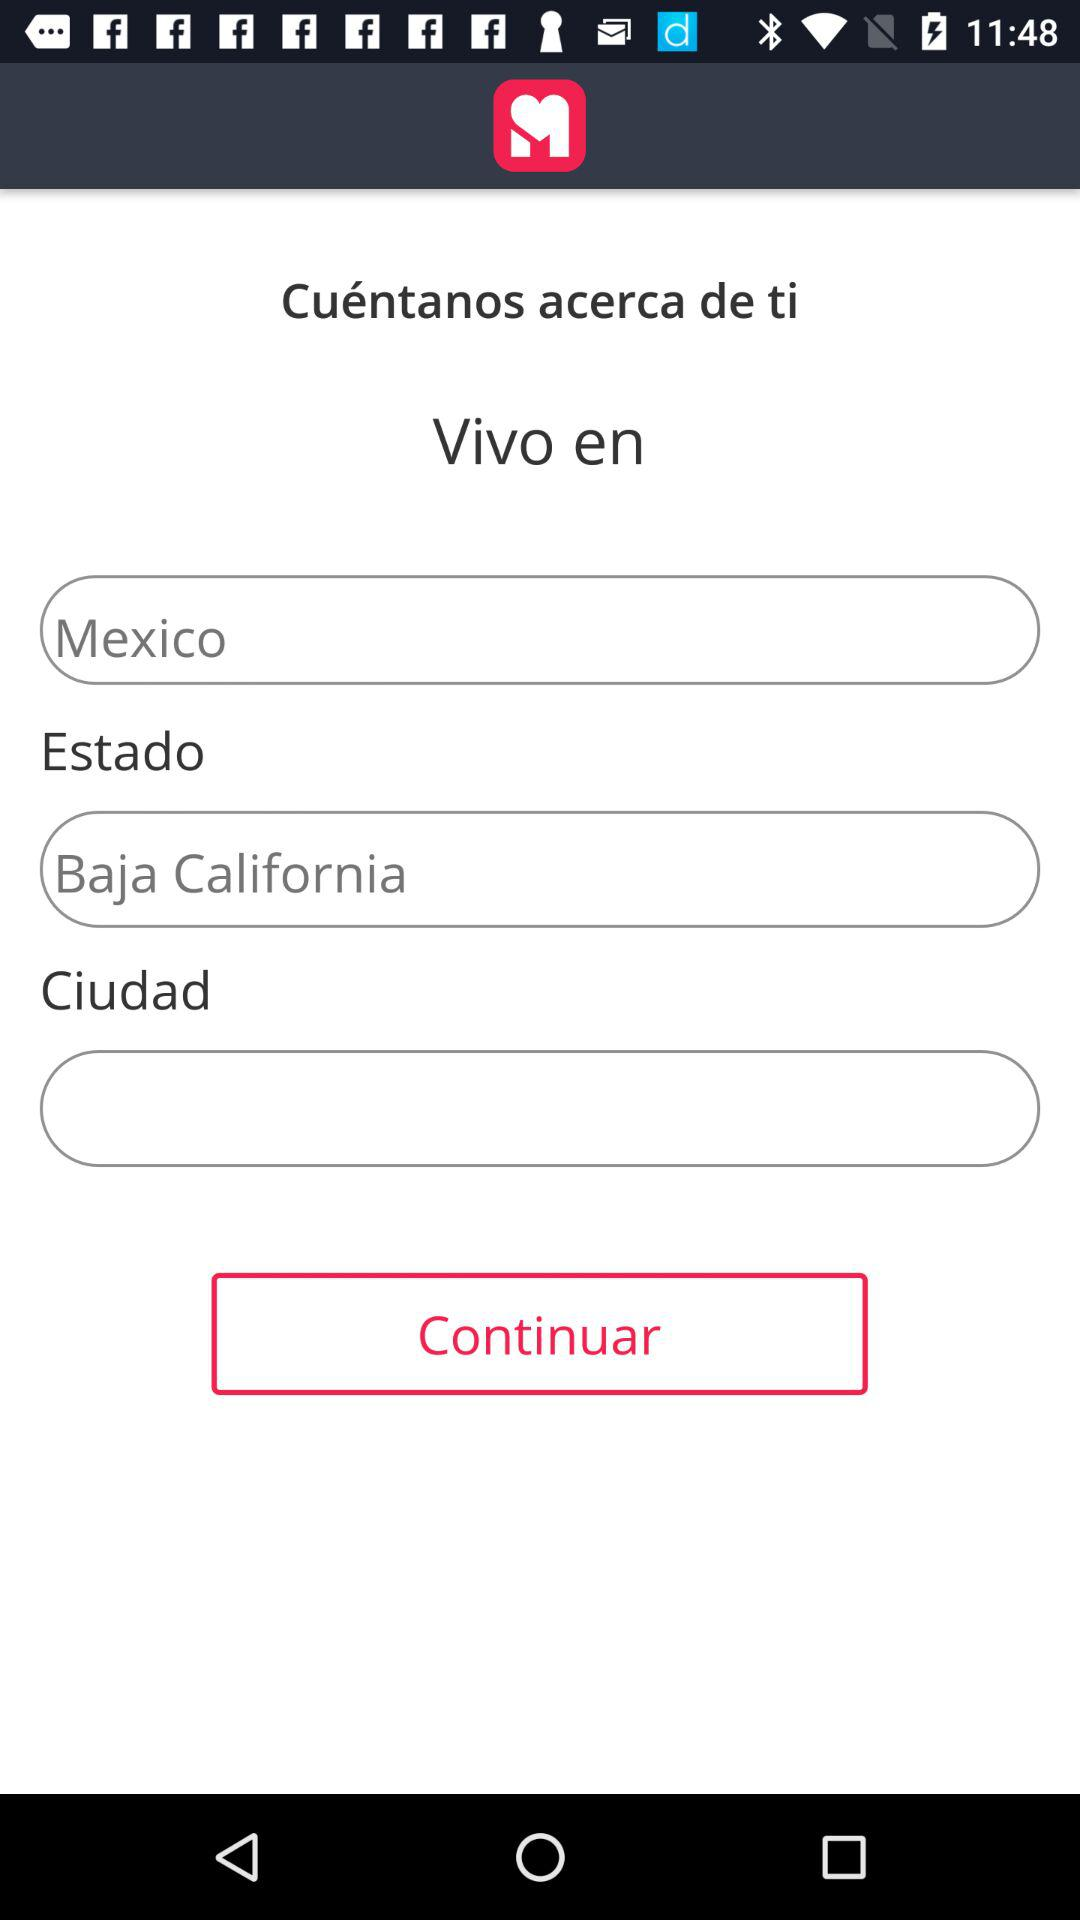How many text inputs are there that are not empty?
Answer the question using a single word or phrase. 2 